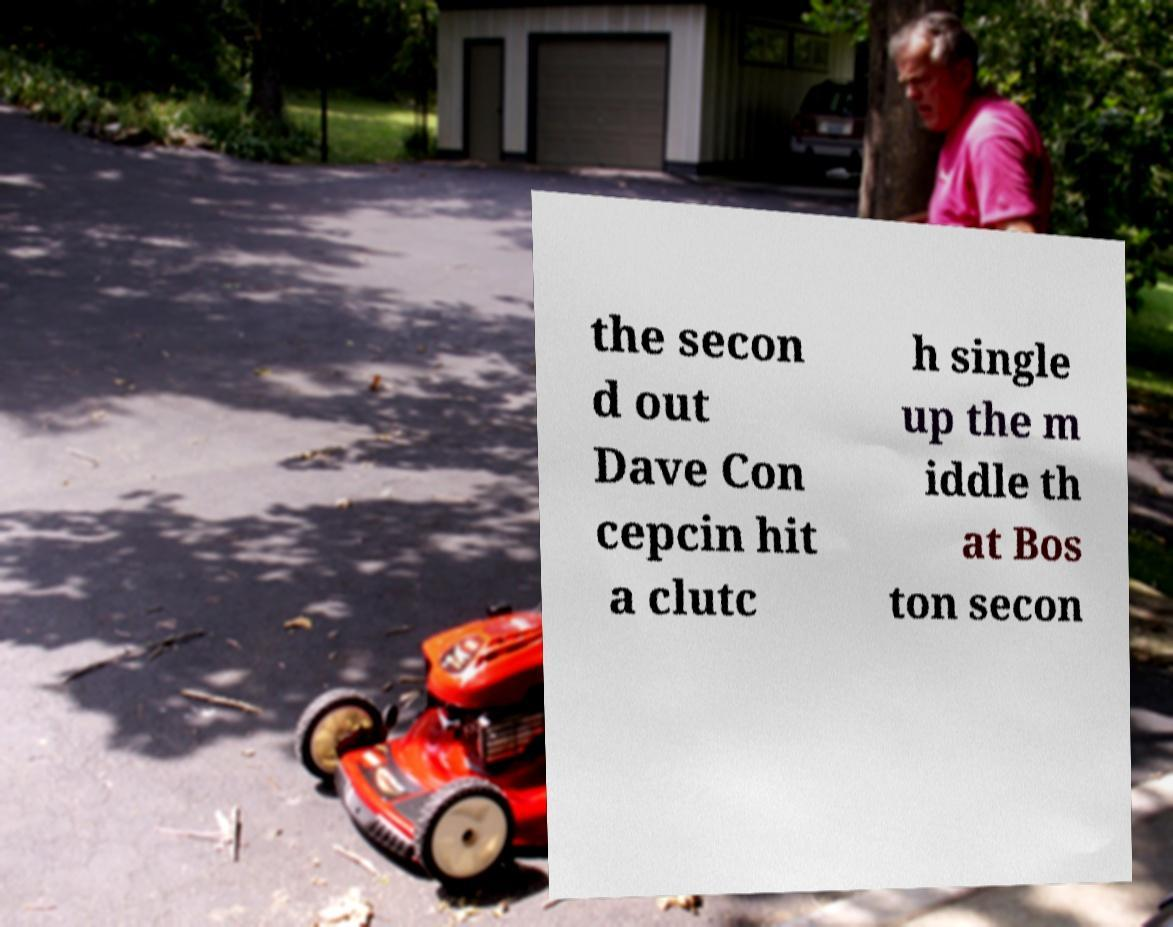There's text embedded in this image that I need extracted. Can you transcribe it verbatim? the secon d out Dave Con cepcin hit a clutc h single up the m iddle th at Bos ton secon 